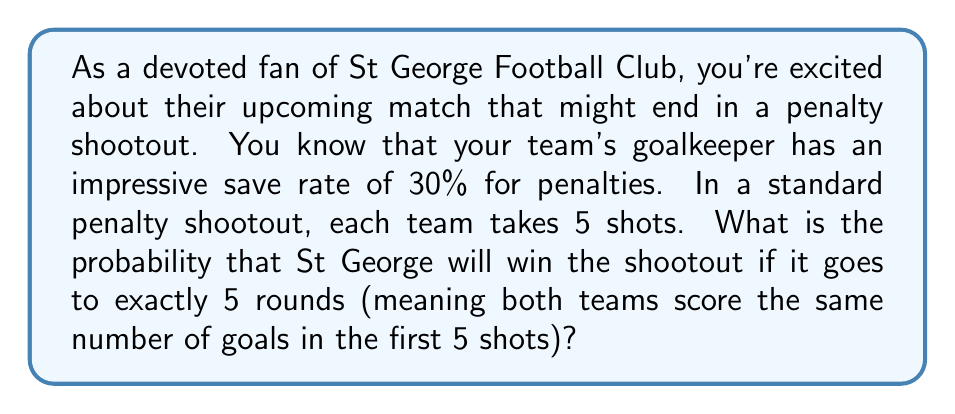Can you answer this question? Let's break this down step-by-step:

1) First, we need to understand what it means for the shootout to go to exactly 5 rounds. This happens when both teams score the same number of goals out of 5 shots.

2) The probability of St George's goalkeeper saving a penalty is 0.3, so the probability of the opponent scoring is 1 - 0.3 = 0.7.

3) For St George to win in this scenario, they need to score more penalties than their opponent in the 5th round.

4) The probability of this happening can be calculated using the binomial distribution:

   $$P(\text{St George wins}) = \sum_{k=0}^4 P(\text{Opponent scores k}) \cdot P(\text{St George scores more than k})$$

5) Let's break this down further:
   
   $$P(\text{Opponent scores k}) = \binom{5}{k} \cdot 0.7^k \cdot 0.3^{5-k}$$
   
   $$P(\text{St George scores more than k}) = \sum_{j=k+1}^5 \binom{5}{j} \cdot 0.8^j \cdot 0.2^{5-j}$$

   Here, we assume St George's penalty takers have a standard 80% success rate.

6) Calculating this for each value of k from 0 to 4:

   For k = 0: $\binom{5}{0} \cdot 0.7^0 \cdot 0.3^5 \cdot (1 - 0.2^5) = 0.00243 \cdot 0.99968 = 0.00243$
   
   For k = 1: $\binom{5}{1} \cdot 0.7^1 \cdot 0.3^4 \cdot (1 - 0.2^4 - \binom{5}{1} \cdot 0.8 \cdot 0.2^4) = 0.02835 \cdot 0.98304 = 0.02787$
   
   For k = 2: $\binom{5}{2} \cdot 0.7^2 \cdot 0.3^3 \cdot (1 - 0.2^3 - \binom{5}{1} \cdot 0.8 \cdot 0.2^3 - \binom{5}{2} \cdot 0.8^2 \cdot 0.2^3) = 0.13230 \cdot 0.89728 = 0.11871$
   
   For k = 3: $\binom{5}{3} \cdot 0.7^3 \cdot 0.3^2 \cdot (1 - 0.2^2 - \binom{5}{1} \cdot 0.8 \cdot 0.2^2 - \binom{5}{2} \cdot 0.8^2 \cdot 0.2^2 - \binom{5}{3} \cdot 0.8^3 \cdot 0.2^2) = 0.30870 \cdot 0.65536 = 0.20234$
   
   For k = 4: $\binom{5}{4} \cdot 0.7^4 \cdot 0.3^1 \cdot (1 - 0.2^1 - \binom{5}{1} \cdot 0.8 \cdot 0.2^1) = 0.36015 \cdot 0.32 = 0.11525$

7) Summing these probabilities:

   $$0.00243 + 0.02787 + 0.11871 + 0.20234 + 0.11525 = 0.46660$$
Answer: The probability that St George Football Club will win the penalty shootout if it goes to exactly 5 rounds is approximately 0.4666 or 46.66%. 